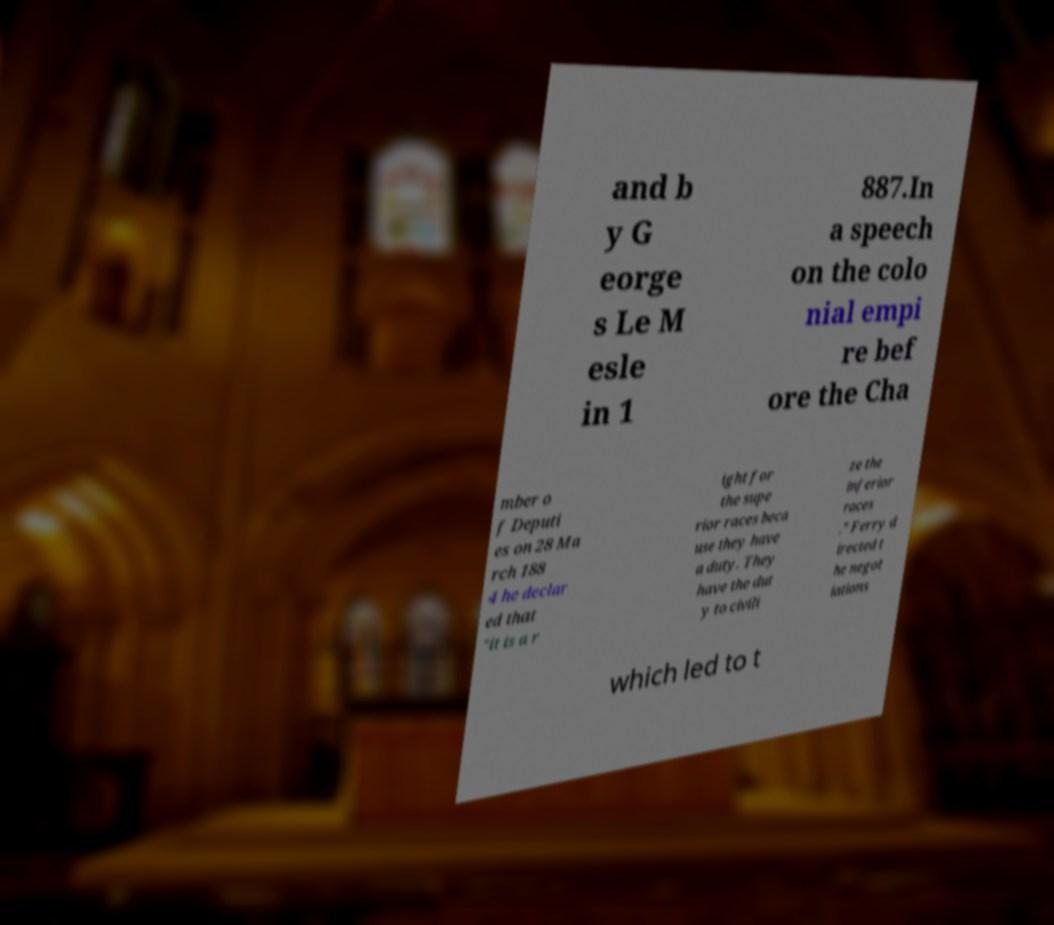Could you extract and type out the text from this image? and b y G eorge s Le M esle in 1 887.In a speech on the colo nial empi re bef ore the Cha mber o f Deputi es on 28 Ma rch 188 4 he declar ed that "it is a r ight for the supe rior races beca use they have a duty. They have the dut y to civili ze the inferior races ." Ferry d irected t he negot iations which led to t 